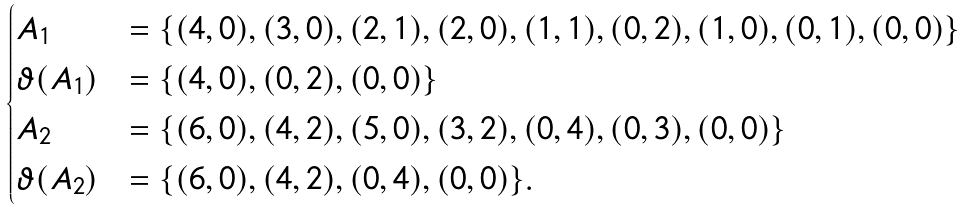Convert formula to latex. <formula><loc_0><loc_0><loc_500><loc_500>\begin{cases} A _ { 1 } & = \{ ( 4 , 0 ) , ( 3 , 0 ) , ( 2 , 1 ) , ( 2 , 0 ) , ( 1 , 1 ) , ( 0 , 2 ) , ( 1 , 0 ) , ( 0 , 1 ) , ( 0 , 0 ) \} \\ \vartheta ( A _ { 1 } ) & = \{ ( 4 , 0 ) , ( 0 , 2 ) , ( 0 , 0 ) \} \\ A _ { 2 } & = \{ ( 6 , 0 ) , ( 4 , 2 ) , ( 5 , 0 ) , ( 3 , 2 ) , ( 0 , 4 ) , ( 0 , 3 ) , ( 0 , 0 ) \} \\ \vartheta ( A _ { 2 } ) & = \{ ( 6 , 0 ) , ( 4 , 2 ) , ( 0 , 4 ) , ( 0 , 0 ) \} . \end{cases}</formula> 